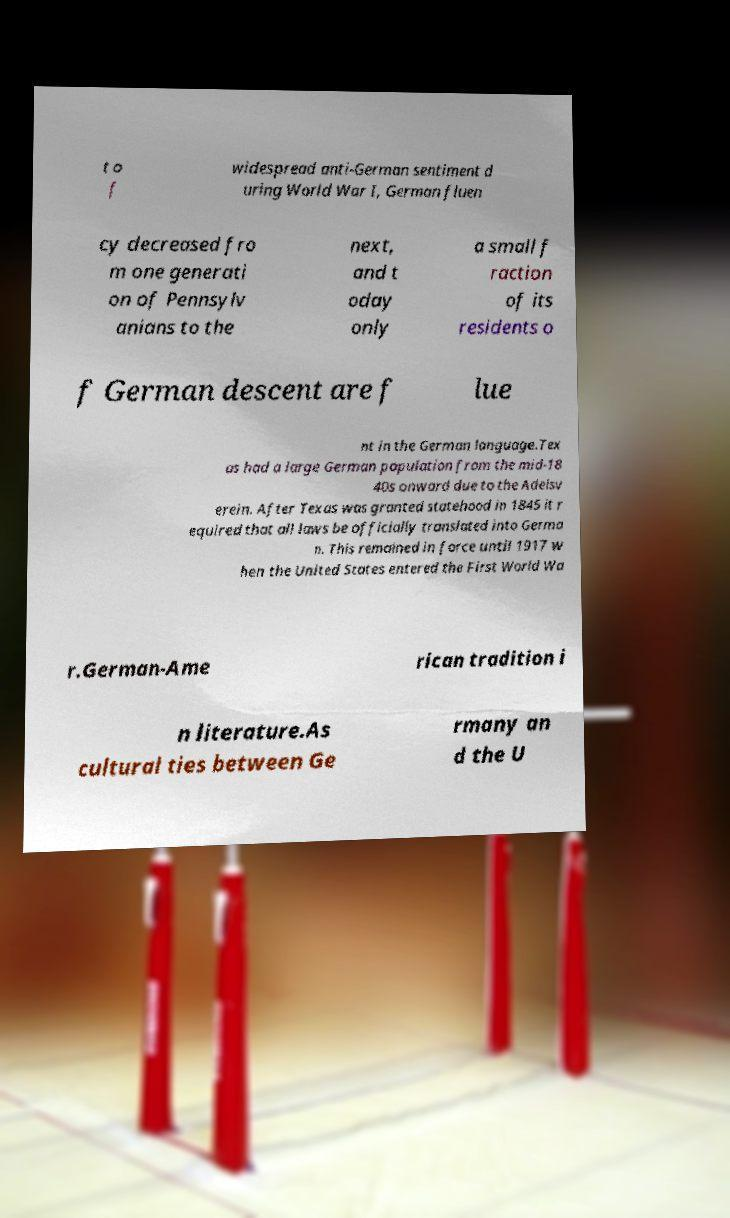I need the written content from this picture converted into text. Can you do that? t o f widespread anti-German sentiment d uring World War I, German fluen cy decreased fro m one generati on of Pennsylv anians to the next, and t oday only a small f raction of its residents o f German descent are f lue nt in the German language.Tex as had a large German population from the mid-18 40s onward due to the Adelsv erein. After Texas was granted statehood in 1845 it r equired that all laws be officially translated into Germa n. This remained in force until 1917 w hen the United States entered the First World Wa r.German-Ame rican tradition i n literature.As cultural ties between Ge rmany an d the U 